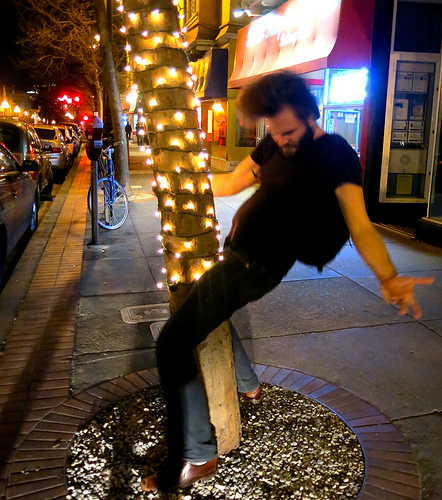<image>
Is there a man on the lights? Yes. Looking at the image, I can see the man is positioned on top of the lights, with the lights providing support. Is the bike behind the tree? Yes. From this viewpoint, the bike is positioned behind the tree, with the tree partially or fully occluding the bike. Is there a man in front of the bike? Yes. The man is positioned in front of the bike, appearing closer to the camera viewpoint. 